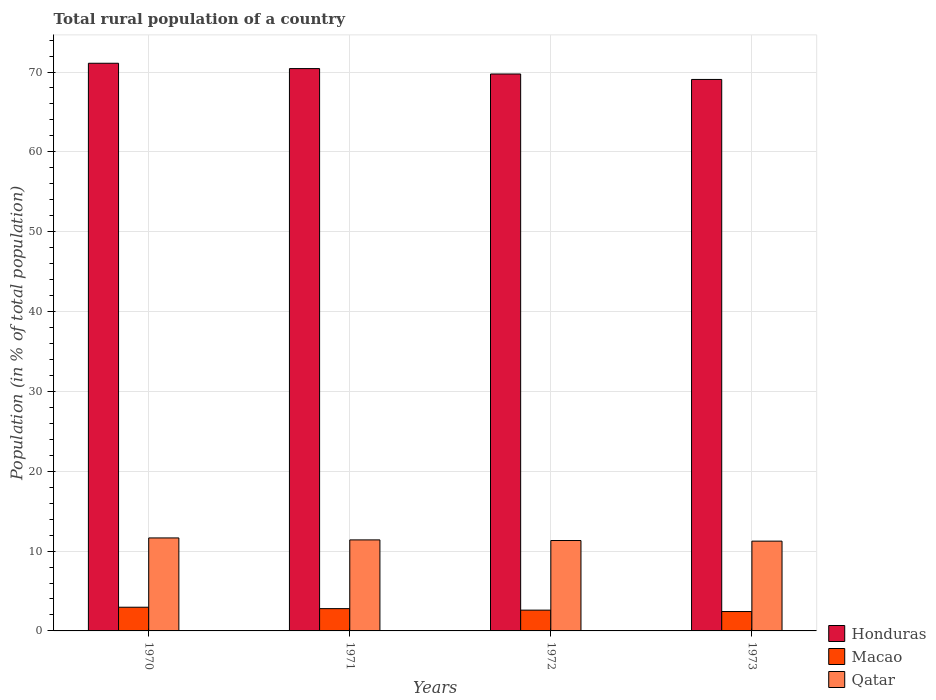How many different coloured bars are there?
Make the answer very short. 3. How many groups of bars are there?
Keep it short and to the point. 4. Are the number of bars on each tick of the X-axis equal?
Your response must be concise. Yes. How many bars are there on the 2nd tick from the left?
Offer a terse response. 3. In how many cases, is the number of bars for a given year not equal to the number of legend labels?
Your answer should be compact. 0. What is the rural population in Macao in 1970?
Ensure brevity in your answer.  2.97. Across all years, what is the maximum rural population in Honduras?
Your response must be concise. 71.1. Across all years, what is the minimum rural population in Qatar?
Your response must be concise. 11.24. In which year was the rural population in Qatar minimum?
Offer a terse response. 1973. What is the total rural population in Macao in the graph?
Your answer should be compact. 10.79. What is the difference between the rural population in Honduras in 1971 and that in 1972?
Your answer should be compact. 0.68. What is the difference between the rural population in Macao in 1973 and the rural population in Qatar in 1971?
Provide a short and direct response. -8.97. What is the average rural population in Qatar per year?
Keep it short and to the point. 11.4. In the year 1973, what is the difference between the rural population in Macao and rural population in Qatar?
Your response must be concise. -8.82. What is the ratio of the rural population in Qatar in 1970 to that in 1973?
Offer a very short reply. 1.04. Is the rural population in Macao in 1971 less than that in 1972?
Keep it short and to the point. No. Is the difference between the rural population in Macao in 1970 and 1973 greater than the difference between the rural population in Qatar in 1970 and 1973?
Make the answer very short. Yes. What is the difference between the highest and the second highest rural population in Honduras?
Your answer should be very brief. 0.67. What is the difference between the highest and the lowest rural population in Honduras?
Your answer should be compact. 2.03. In how many years, is the rural population in Honduras greater than the average rural population in Honduras taken over all years?
Your answer should be very brief. 2. What does the 3rd bar from the left in 1970 represents?
Provide a succinct answer. Qatar. What does the 3rd bar from the right in 1970 represents?
Provide a succinct answer. Honduras. Is it the case that in every year, the sum of the rural population in Honduras and rural population in Qatar is greater than the rural population in Macao?
Offer a very short reply. Yes. How many bars are there?
Make the answer very short. 12. Are all the bars in the graph horizontal?
Ensure brevity in your answer.  No. How many years are there in the graph?
Ensure brevity in your answer.  4. Does the graph contain any zero values?
Offer a terse response. No. Does the graph contain grids?
Provide a succinct answer. Yes. Where does the legend appear in the graph?
Your answer should be very brief. Bottom right. How many legend labels are there?
Keep it short and to the point. 3. What is the title of the graph?
Keep it short and to the point. Total rural population of a country. What is the label or title of the Y-axis?
Offer a very short reply. Population (in % of total population). What is the Population (in % of total population) in Honduras in 1970?
Make the answer very short. 71.1. What is the Population (in % of total population) of Macao in 1970?
Give a very brief answer. 2.97. What is the Population (in % of total population) in Qatar in 1970?
Ensure brevity in your answer.  11.65. What is the Population (in % of total population) of Honduras in 1971?
Your answer should be very brief. 70.43. What is the Population (in % of total population) of Macao in 1971?
Give a very brief answer. 2.79. What is the Population (in % of total population) in Honduras in 1972?
Your response must be concise. 69.75. What is the Population (in % of total population) in Macao in 1972?
Offer a very short reply. 2.6. What is the Population (in % of total population) of Qatar in 1972?
Your response must be concise. 11.32. What is the Population (in % of total population) in Honduras in 1973?
Make the answer very short. 69.07. What is the Population (in % of total population) in Macao in 1973?
Provide a short and direct response. 2.43. What is the Population (in % of total population) of Qatar in 1973?
Provide a short and direct response. 11.24. Across all years, what is the maximum Population (in % of total population) of Honduras?
Give a very brief answer. 71.1. Across all years, what is the maximum Population (in % of total population) of Macao?
Your answer should be very brief. 2.97. Across all years, what is the maximum Population (in % of total population) in Qatar?
Offer a terse response. 11.65. Across all years, what is the minimum Population (in % of total population) in Honduras?
Provide a succinct answer. 69.07. Across all years, what is the minimum Population (in % of total population) in Macao?
Your response must be concise. 2.43. Across all years, what is the minimum Population (in % of total population) in Qatar?
Your response must be concise. 11.24. What is the total Population (in % of total population) of Honduras in the graph?
Provide a succinct answer. 280.35. What is the total Population (in % of total population) of Macao in the graph?
Provide a succinct answer. 10.79. What is the total Population (in % of total population) in Qatar in the graph?
Give a very brief answer. 45.61. What is the difference between the Population (in % of total population) of Honduras in 1970 and that in 1971?
Offer a very short reply. 0.67. What is the difference between the Population (in % of total population) in Macao in 1970 and that in 1971?
Provide a succinct answer. 0.18. What is the difference between the Population (in % of total population) in Qatar in 1970 and that in 1971?
Your response must be concise. 0.25. What is the difference between the Population (in % of total population) in Honduras in 1970 and that in 1972?
Keep it short and to the point. 1.34. What is the difference between the Population (in % of total population) of Macao in 1970 and that in 1972?
Offer a very short reply. 0.36. What is the difference between the Population (in % of total population) in Qatar in 1970 and that in 1972?
Make the answer very short. 0.32. What is the difference between the Population (in % of total population) of Honduras in 1970 and that in 1973?
Your response must be concise. 2.03. What is the difference between the Population (in % of total population) of Macao in 1970 and that in 1973?
Give a very brief answer. 0.54. What is the difference between the Population (in % of total population) of Qatar in 1970 and that in 1973?
Provide a short and direct response. 0.4. What is the difference between the Population (in % of total population) in Honduras in 1971 and that in 1972?
Ensure brevity in your answer.  0.68. What is the difference between the Population (in % of total population) in Macao in 1971 and that in 1972?
Provide a short and direct response. 0.19. What is the difference between the Population (in % of total population) in Qatar in 1971 and that in 1972?
Your answer should be very brief. 0.08. What is the difference between the Population (in % of total population) in Honduras in 1971 and that in 1973?
Offer a very short reply. 1.36. What is the difference between the Population (in % of total population) of Macao in 1971 and that in 1973?
Give a very brief answer. 0.36. What is the difference between the Population (in % of total population) of Qatar in 1971 and that in 1973?
Your answer should be compact. 0.15. What is the difference between the Population (in % of total population) in Honduras in 1972 and that in 1973?
Give a very brief answer. 0.68. What is the difference between the Population (in % of total population) of Macao in 1972 and that in 1973?
Give a very brief answer. 0.18. What is the difference between the Population (in % of total population) in Qatar in 1972 and that in 1973?
Your answer should be compact. 0.08. What is the difference between the Population (in % of total population) of Honduras in 1970 and the Population (in % of total population) of Macao in 1971?
Offer a very short reply. 68.31. What is the difference between the Population (in % of total population) in Honduras in 1970 and the Population (in % of total population) in Qatar in 1971?
Provide a short and direct response. 59.7. What is the difference between the Population (in % of total population) of Macao in 1970 and the Population (in % of total population) of Qatar in 1971?
Give a very brief answer. -8.43. What is the difference between the Population (in % of total population) in Honduras in 1970 and the Population (in % of total population) in Macao in 1972?
Your response must be concise. 68.5. What is the difference between the Population (in % of total population) of Honduras in 1970 and the Population (in % of total population) of Qatar in 1972?
Your answer should be very brief. 59.78. What is the difference between the Population (in % of total population) of Macao in 1970 and the Population (in % of total population) of Qatar in 1972?
Ensure brevity in your answer.  -8.35. What is the difference between the Population (in % of total population) in Honduras in 1970 and the Population (in % of total population) in Macao in 1973?
Your answer should be very brief. 68.67. What is the difference between the Population (in % of total population) in Honduras in 1970 and the Population (in % of total population) in Qatar in 1973?
Keep it short and to the point. 59.85. What is the difference between the Population (in % of total population) of Macao in 1970 and the Population (in % of total population) of Qatar in 1973?
Your response must be concise. -8.28. What is the difference between the Population (in % of total population) in Honduras in 1971 and the Population (in % of total population) in Macao in 1972?
Keep it short and to the point. 67.83. What is the difference between the Population (in % of total population) in Honduras in 1971 and the Population (in % of total population) in Qatar in 1972?
Offer a very short reply. 59.11. What is the difference between the Population (in % of total population) in Macao in 1971 and the Population (in % of total population) in Qatar in 1972?
Your response must be concise. -8.53. What is the difference between the Population (in % of total population) in Honduras in 1971 and the Population (in % of total population) in Macao in 1973?
Provide a short and direct response. 68. What is the difference between the Population (in % of total population) of Honduras in 1971 and the Population (in % of total population) of Qatar in 1973?
Offer a very short reply. 59.19. What is the difference between the Population (in % of total population) of Macao in 1971 and the Population (in % of total population) of Qatar in 1973?
Offer a very short reply. -8.45. What is the difference between the Population (in % of total population) in Honduras in 1972 and the Population (in % of total population) in Macao in 1973?
Ensure brevity in your answer.  67.33. What is the difference between the Population (in % of total population) in Honduras in 1972 and the Population (in % of total population) in Qatar in 1973?
Your answer should be compact. 58.51. What is the difference between the Population (in % of total population) of Macao in 1972 and the Population (in % of total population) of Qatar in 1973?
Provide a short and direct response. -8.64. What is the average Population (in % of total population) of Honduras per year?
Provide a short and direct response. 70.09. What is the average Population (in % of total population) in Macao per year?
Ensure brevity in your answer.  2.7. What is the average Population (in % of total population) in Qatar per year?
Provide a short and direct response. 11.4. In the year 1970, what is the difference between the Population (in % of total population) in Honduras and Population (in % of total population) in Macao?
Offer a terse response. 68.13. In the year 1970, what is the difference between the Population (in % of total population) of Honduras and Population (in % of total population) of Qatar?
Offer a very short reply. 59.45. In the year 1970, what is the difference between the Population (in % of total population) in Macao and Population (in % of total population) in Qatar?
Your answer should be compact. -8.68. In the year 1971, what is the difference between the Population (in % of total population) of Honduras and Population (in % of total population) of Macao?
Ensure brevity in your answer.  67.64. In the year 1971, what is the difference between the Population (in % of total population) of Honduras and Population (in % of total population) of Qatar?
Give a very brief answer. 59.03. In the year 1971, what is the difference between the Population (in % of total population) in Macao and Population (in % of total population) in Qatar?
Your response must be concise. -8.61. In the year 1972, what is the difference between the Population (in % of total population) in Honduras and Population (in % of total population) in Macao?
Your response must be concise. 67.15. In the year 1972, what is the difference between the Population (in % of total population) in Honduras and Population (in % of total population) in Qatar?
Provide a short and direct response. 58.43. In the year 1972, what is the difference between the Population (in % of total population) of Macao and Population (in % of total population) of Qatar?
Your answer should be compact. -8.72. In the year 1973, what is the difference between the Population (in % of total population) of Honduras and Population (in % of total population) of Macao?
Provide a short and direct response. 66.64. In the year 1973, what is the difference between the Population (in % of total population) in Honduras and Population (in % of total population) in Qatar?
Provide a succinct answer. 57.83. In the year 1973, what is the difference between the Population (in % of total population) of Macao and Population (in % of total population) of Qatar?
Keep it short and to the point. -8.82. What is the ratio of the Population (in % of total population) of Honduras in 1970 to that in 1971?
Provide a short and direct response. 1.01. What is the ratio of the Population (in % of total population) of Macao in 1970 to that in 1971?
Your answer should be very brief. 1.06. What is the ratio of the Population (in % of total population) of Qatar in 1970 to that in 1971?
Offer a terse response. 1.02. What is the ratio of the Population (in % of total population) in Honduras in 1970 to that in 1972?
Ensure brevity in your answer.  1.02. What is the ratio of the Population (in % of total population) in Macao in 1970 to that in 1972?
Your answer should be compact. 1.14. What is the ratio of the Population (in % of total population) in Qatar in 1970 to that in 1972?
Make the answer very short. 1.03. What is the ratio of the Population (in % of total population) of Honduras in 1970 to that in 1973?
Provide a succinct answer. 1.03. What is the ratio of the Population (in % of total population) in Macao in 1970 to that in 1973?
Offer a terse response. 1.22. What is the ratio of the Population (in % of total population) of Qatar in 1970 to that in 1973?
Make the answer very short. 1.04. What is the ratio of the Population (in % of total population) in Honduras in 1971 to that in 1972?
Keep it short and to the point. 1.01. What is the ratio of the Population (in % of total population) in Macao in 1971 to that in 1972?
Provide a short and direct response. 1.07. What is the ratio of the Population (in % of total population) of Honduras in 1971 to that in 1973?
Give a very brief answer. 1.02. What is the ratio of the Population (in % of total population) of Macao in 1971 to that in 1973?
Offer a terse response. 1.15. What is the ratio of the Population (in % of total population) of Qatar in 1971 to that in 1973?
Make the answer very short. 1.01. What is the ratio of the Population (in % of total population) in Honduras in 1972 to that in 1973?
Keep it short and to the point. 1.01. What is the ratio of the Population (in % of total population) in Macao in 1972 to that in 1973?
Your answer should be very brief. 1.07. What is the ratio of the Population (in % of total population) of Qatar in 1972 to that in 1973?
Ensure brevity in your answer.  1.01. What is the difference between the highest and the second highest Population (in % of total population) of Honduras?
Your answer should be very brief. 0.67. What is the difference between the highest and the second highest Population (in % of total population) of Macao?
Your answer should be compact. 0.18. What is the difference between the highest and the second highest Population (in % of total population) of Qatar?
Ensure brevity in your answer.  0.25. What is the difference between the highest and the lowest Population (in % of total population) of Honduras?
Your response must be concise. 2.03. What is the difference between the highest and the lowest Population (in % of total population) of Macao?
Your answer should be very brief. 0.54. What is the difference between the highest and the lowest Population (in % of total population) in Qatar?
Your response must be concise. 0.4. 